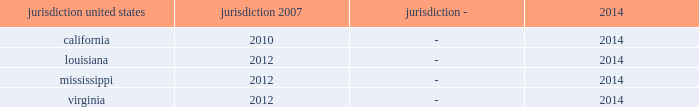Interest and penalties with respect to unrecognized tax benefits were $ 3 million as of each of december 31 , 2015 and 2014 .
During 2013 , the company recorded a reduction of $ 14 million to its liability for uncertain tax positions related to a change approved by the irs for the allocation of interest costs to long term construction contracts at ingalls .
This change was made on a prospective basis only and did not impact the tax returns filed for years prior to 2013 .
The table summarizes the tax years that are either currently under examination or remain open under the applicable statute of limitations and subject to examination by the major tax jurisdictions in which the company operates: .
Although the company believes it has adequately provided for all uncertain tax positions , amounts asserted by taxing authorities could be greater than the company's accrued position .
Accordingly , additional provisions for federal and state income tax related matters could be recorded in the future as revised estimates are made or the underlying matters are effectively settled or otherwise resolved .
Conversely , the company could settle positions with the tax authorities for amounts lower than have been accrued .
The company believes that it is reasonably possible that during the next 12 months the company's liability for uncertain tax positions may decrease by approximately $ 2 million due to statute of limitation expirations .
The company recognizes accrued interest and penalties related to uncertain tax positions in income tax expense .
The irs is currently conducting an examination of northrop grumman's consolidated tax returns , of which hii was part , for the years 2007 through the spin-off .
During 2013 the company entered into the pre-compliance assurance process with the irs for years 2011 and 2012 .
The company is part of the irs compliance assurance process program for the 2014 , 2015 , and 2016 tax years .
Open tax years related to state jurisdictions remain subject to examination .
As of march 31 , 2011 , the date of the spin-off , the company's liability for uncertain tax positions was approximately $ 4 million , net of federal benefit , which related solely to state income tax positions .
Under the terms of the separation agreement , northrop grumman is obligated to reimburse hii for any settlement liabilities paid by hii to any government authority for tax periods prior to the spin-off , which include state income taxes .
As a result , the company recorded in other assets a reimbursement receivable of approximately $ 4 million , net of federal benefit , related to uncertain tax positions for state income taxes as of the date of the spin-off .
In 2014 , the statute of limitations expired for the $ 4 million liability related to state uncertain tax positions as of the spin-off date .
Accordingly , the $ 4 million liability and the associated reimbursement receivable were written off .
On september 13 , 2013 , the treasury department and the internal revenue service issued final regulations regarding the deduction and capitalization of amounts paid to acquire , produce , improve , or dispose of tangible personal property .
These regulations are generally effective for tax years beginning on or after january 1 , 2014 .
The application of these regulations did not have a material impact on the company's consolidated financial statements .
Deferred income taxes - deferred income taxes reflect the net tax effects of temporary differences between the carrying amounts of assets and liabilities for financial reporting purposes and for income tax purposes .
Such amounts are classified in the consolidated statements of financial position as current or non-current assets or liabilities based upon the classification of the related assets and liabilities. .
What is the current tax examination period in california , in years? 
Computations: (2014 - 2010)
Answer: 4.0. 